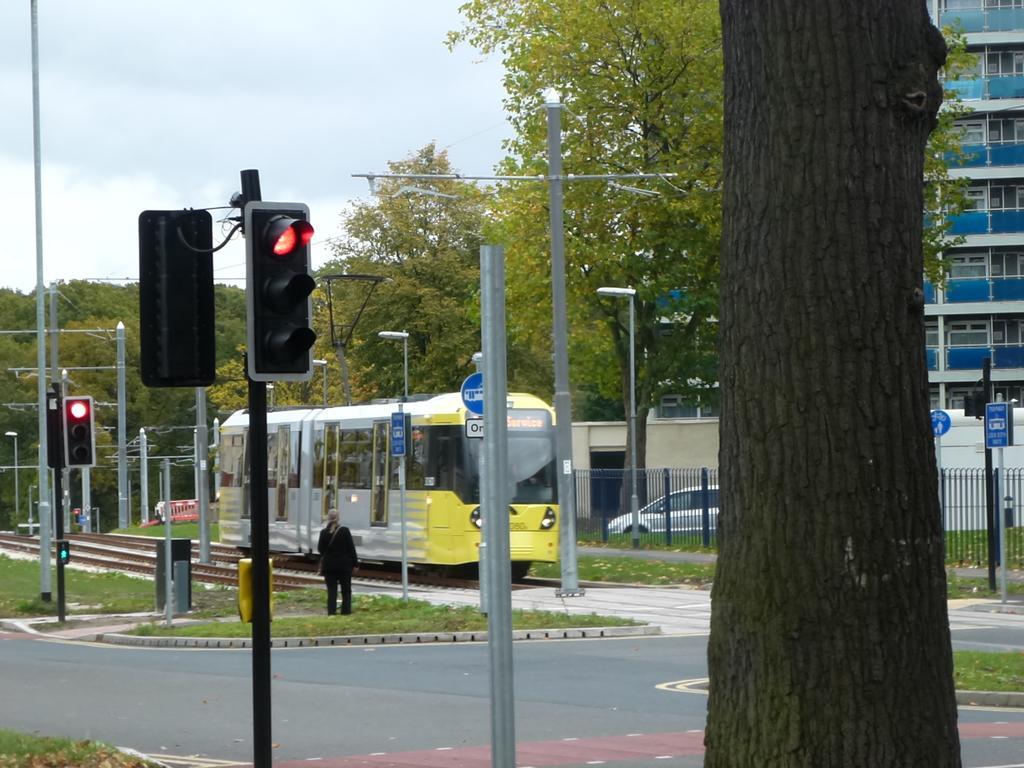Can you describe this image briefly? In this picture we can see few traffic lights, poles, lights, trees, sign boards and buildings, and also we can see a train on the tracks, beside to the train we can find a person, in the background we can find metal fence and a car. 